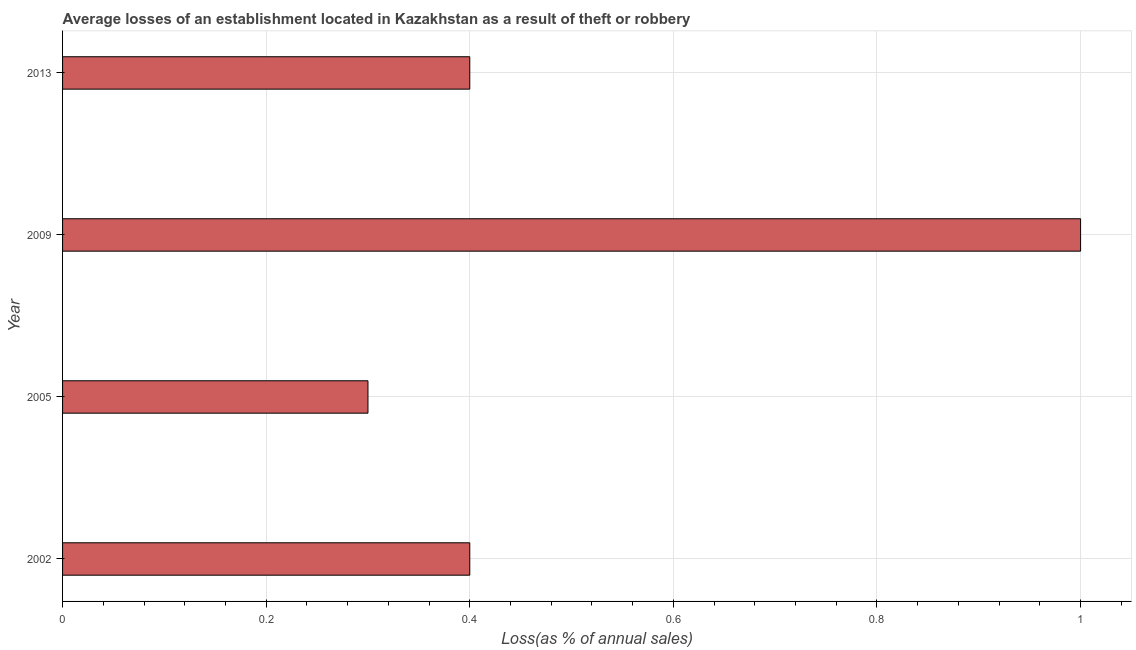Does the graph contain any zero values?
Your response must be concise. No. What is the title of the graph?
Your answer should be compact. Average losses of an establishment located in Kazakhstan as a result of theft or robbery. What is the label or title of the X-axis?
Make the answer very short. Loss(as % of annual sales). Across all years, what is the maximum losses due to theft?
Keep it short and to the point. 1. Across all years, what is the minimum losses due to theft?
Your response must be concise. 0.3. What is the sum of the losses due to theft?
Offer a very short reply. 2.1. What is the average losses due to theft per year?
Keep it short and to the point. 0.53. Do a majority of the years between 2002 and 2009 (inclusive) have losses due to theft greater than 0.04 %?
Ensure brevity in your answer.  Yes. What is the ratio of the losses due to theft in 2005 to that in 2013?
Make the answer very short. 0.75. Is the losses due to theft in 2002 less than that in 2013?
Your answer should be very brief. No. Is the difference between the losses due to theft in 2005 and 2013 greater than the difference between any two years?
Offer a very short reply. No. What is the difference between the highest and the second highest losses due to theft?
Your answer should be very brief. 0.6. Are all the bars in the graph horizontal?
Your answer should be very brief. Yes. What is the Loss(as % of annual sales) of 2009?
Offer a terse response. 1. What is the difference between the Loss(as % of annual sales) in 2002 and 2009?
Give a very brief answer. -0.6. What is the difference between the Loss(as % of annual sales) in 2002 and 2013?
Give a very brief answer. 0. What is the difference between the Loss(as % of annual sales) in 2005 and 2013?
Your answer should be compact. -0.1. What is the ratio of the Loss(as % of annual sales) in 2002 to that in 2005?
Make the answer very short. 1.33. What is the ratio of the Loss(as % of annual sales) in 2005 to that in 2009?
Your answer should be very brief. 0.3. What is the ratio of the Loss(as % of annual sales) in 2005 to that in 2013?
Offer a terse response. 0.75. What is the ratio of the Loss(as % of annual sales) in 2009 to that in 2013?
Give a very brief answer. 2.5. 